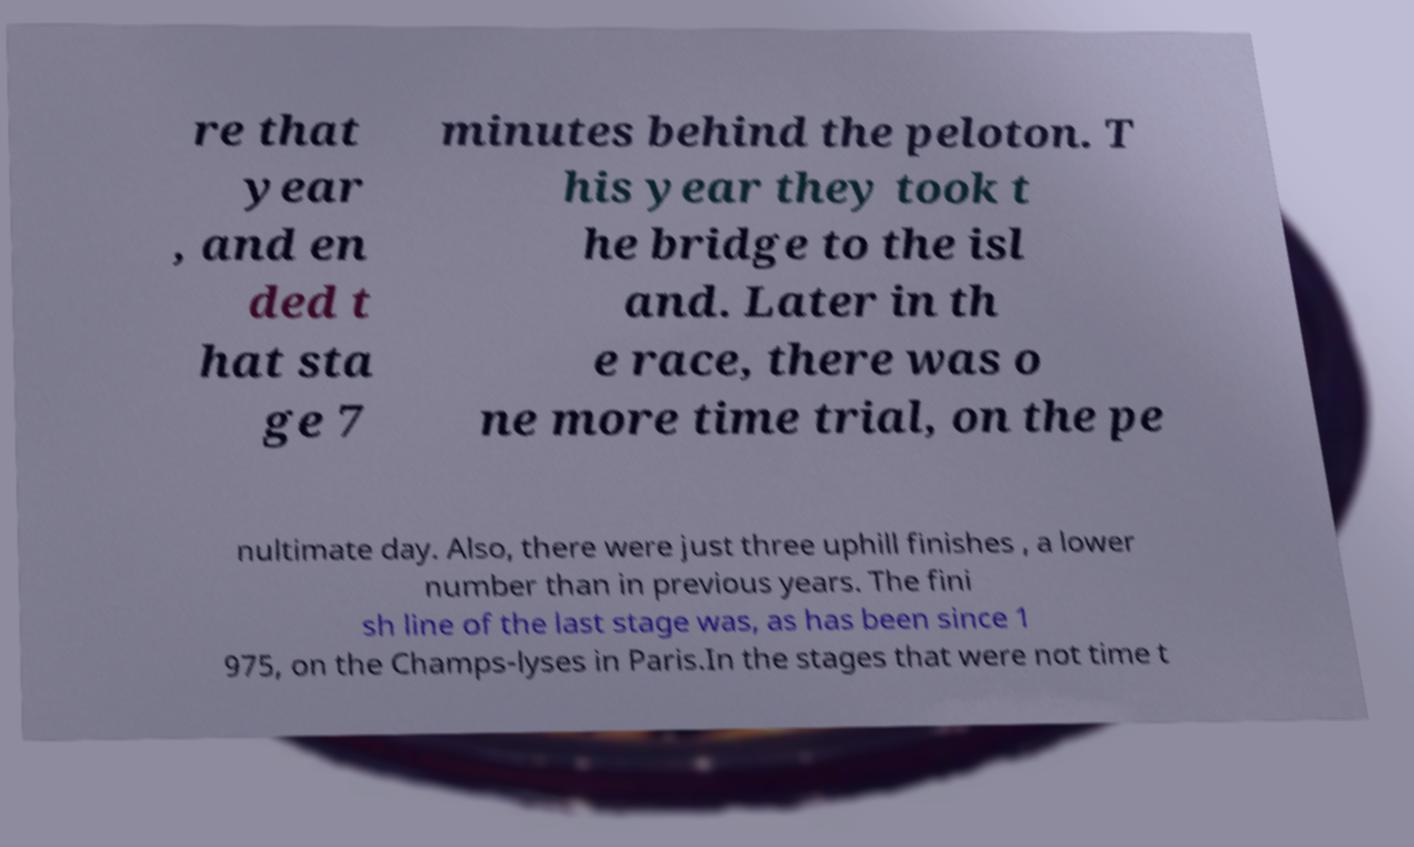I need the written content from this picture converted into text. Can you do that? re that year , and en ded t hat sta ge 7 minutes behind the peloton. T his year they took t he bridge to the isl and. Later in th e race, there was o ne more time trial, on the pe nultimate day. Also, there were just three uphill finishes , a lower number than in previous years. The fini sh line of the last stage was, as has been since 1 975, on the Champs-lyses in Paris.In the stages that were not time t 